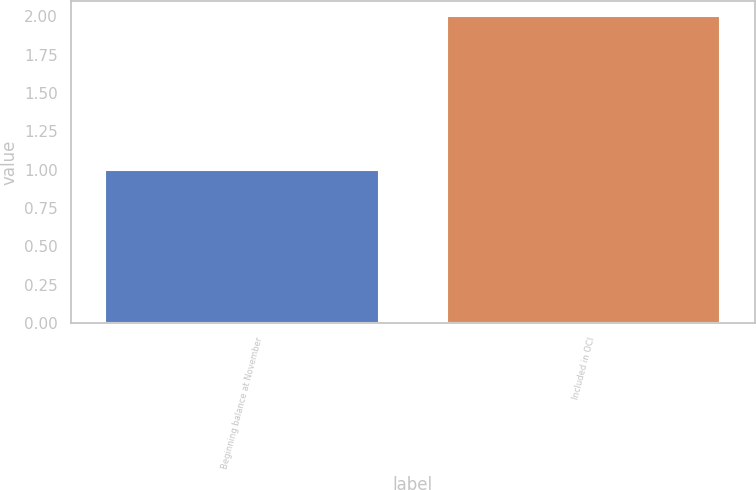<chart> <loc_0><loc_0><loc_500><loc_500><bar_chart><fcel>Beginning balance at November<fcel>Included in OCI<nl><fcel>1<fcel>2<nl></chart> 